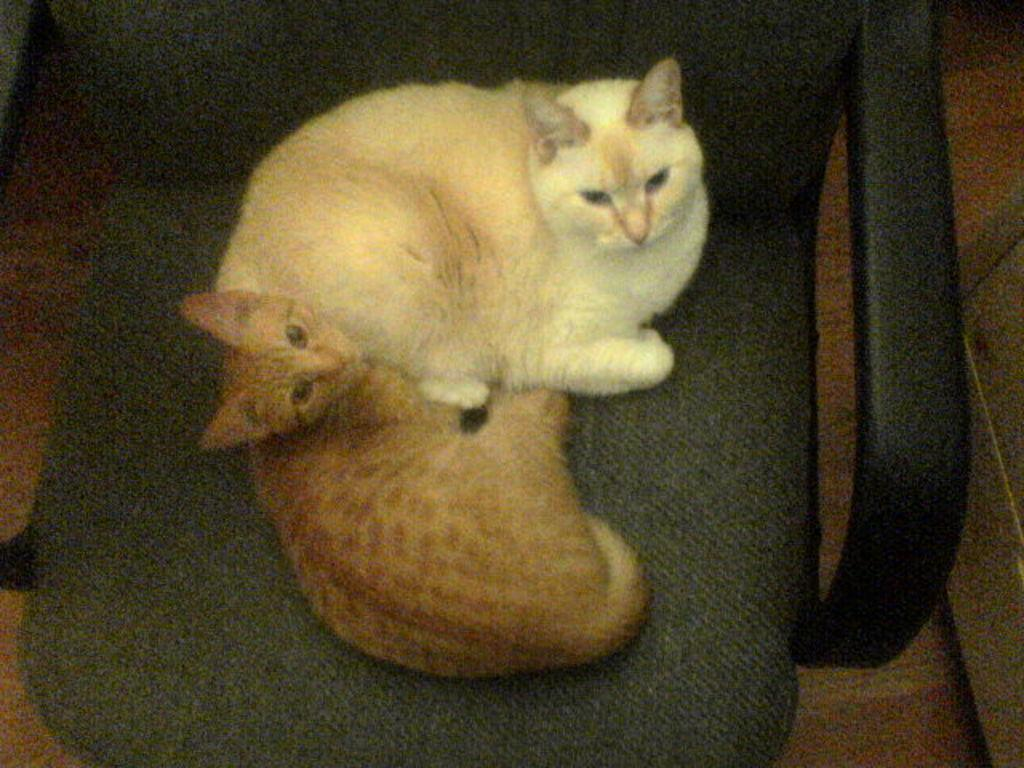How many cats are in the image? There are two cats in the image. What are the cats doing in the image? The cats are sitting on a chair. What can be seen on the right side of the image? There is a table on the right side of the image. What part of the room is visible at the bottom of the image? The floor is visible at the bottom of the image. What type of view can be seen from the window in the image? There is no window present in the image, so it is not possible to determine the view. 